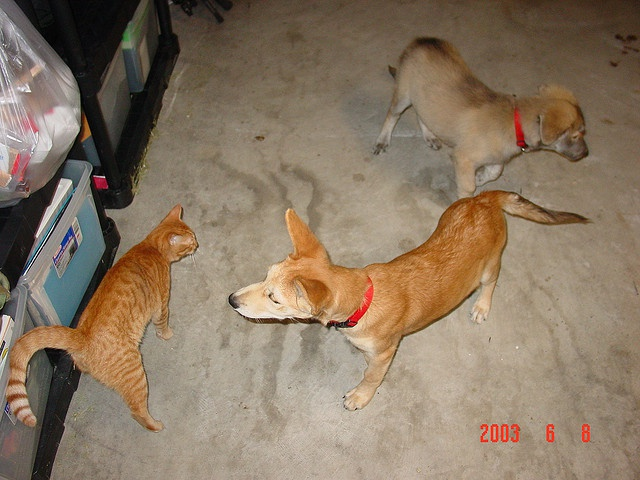Describe the objects in this image and their specific colors. I can see dog in gray, red, and tan tones, dog in gray and maroon tones, and cat in gray, brown, and tan tones in this image. 